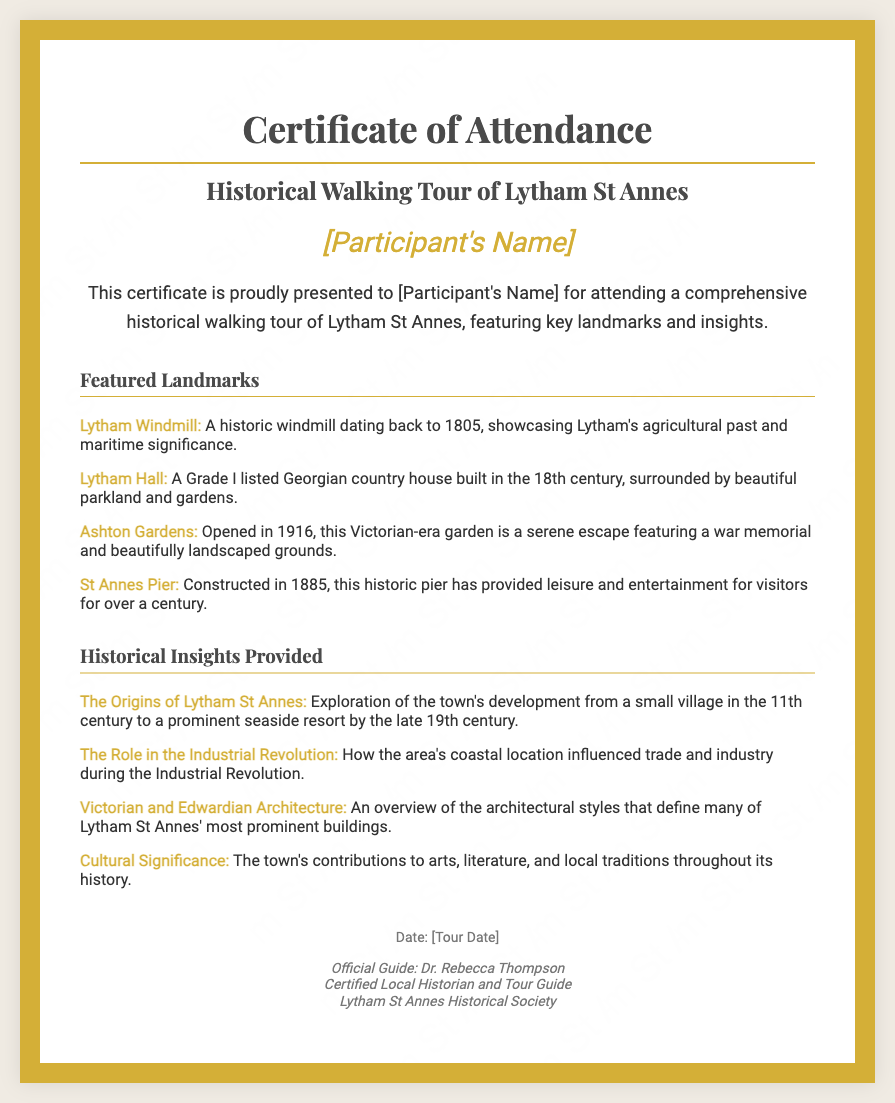what is the title of the document? The title mentioned in the document is the "Certificate of Attendance - Historical Walking Tour of Lytham St Annes."
Answer: Certificate of Attendance - Historical Walking Tour of Lytham St Annes who is the official guide for the tour? The document states that the official guide is Dr. Rebecca Thompson.
Answer: Dr. Rebecca Thompson what is the date format used in the certificate? The document mentions a placeholder for the tour date as "[Tour Date]," indicating a specific date would be filled in.
Answer: [Tour Date] how many featured landmarks are listed in the certificate? There are four featured landmarks mentioned in the document.
Answer: 4 what significant year is associated with Lytham Windmill? The certificate specifies that Lytham Windmill dates back to 1805.
Answer: 1805 what was Lytham St Annes' status in the 19th century? The document explains that Lytham St Annes developed into a prominent seaside resort by the late 19th century.
Answer: prominent seaside resort what is the significance of St Annes Pier? The document indicates that it has provided leisure and entertainment for over a century, having been constructed in 1885.
Answer: leisure and entertainment what is the main purpose of the certificate? The purpose of the certificate is to acknowledge attendance at a historical walking tour.
Answer: to acknowledge attendance what is the architectural style discussed in the insights section? The document discusses Victorian and Edwardian architecture as part of the historical insights.
Answer: Victorian and Edwardian architecture 